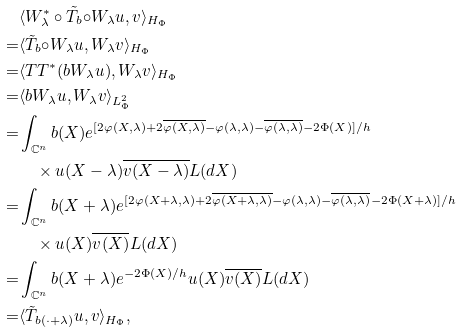<formula> <loc_0><loc_0><loc_500><loc_500>& \langle { W _ { \lambda } ^ { \ast } \circ \tilde { T } _ { b } { \circ } W _ { \lambda } u , v } \rangle _ { H _ { \Phi } } \\ = & \langle { \tilde { T } _ { b } { \circ } W _ { \lambda } u , W _ { \lambda } v } \rangle _ { H _ { \Phi } } \\ = & \langle { T T ^ { \ast } ( b W _ { \lambda } u ) , W _ { \lambda } v } \rangle _ { H _ { \Phi } } \\ = & \langle { b W _ { \lambda } u , W _ { \lambda } v } \rangle _ { L ^ { 2 } _ { \Phi } } \\ = & \int _ { \mathbb { C } ^ { n } } b ( X ) e ^ { [ 2 \varphi ( X , \lambda ) + 2 \overline { \varphi ( X , \lambda ) } - \varphi ( \lambda , \lambda ) - \overline { \varphi ( \lambda , \lambda ) } - 2 \Phi ( X ) ] / h } \\ & \quad \times u ( X - \lambda ) \overline { v ( X - \lambda ) } L ( d X ) \\ = & \int _ { \mathbb { C } ^ { n } } b ( X + \lambda ) e ^ { [ 2 \varphi ( X + \lambda , \lambda ) + 2 \overline { \varphi ( X + \lambda , \lambda ) } - \varphi ( \lambda , \lambda ) - \overline { \varphi ( \lambda , \lambda ) } - 2 \Phi ( X + \lambda ) ] / h } \\ & \quad \times u ( X ) \overline { v ( X ) } L ( d X ) \\ = & \int _ { \mathbb { C } ^ { n } } b ( X + \lambda ) e ^ { - 2 \Phi ( X ) / h } u ( X ) \overline { v ( X ) } L ( d X ) \\ = & \langle \tilde { T } _ { b ( \cdot + \lambda ) } u , v \rangle _ { H _ { \Phi } } ,</formula> 